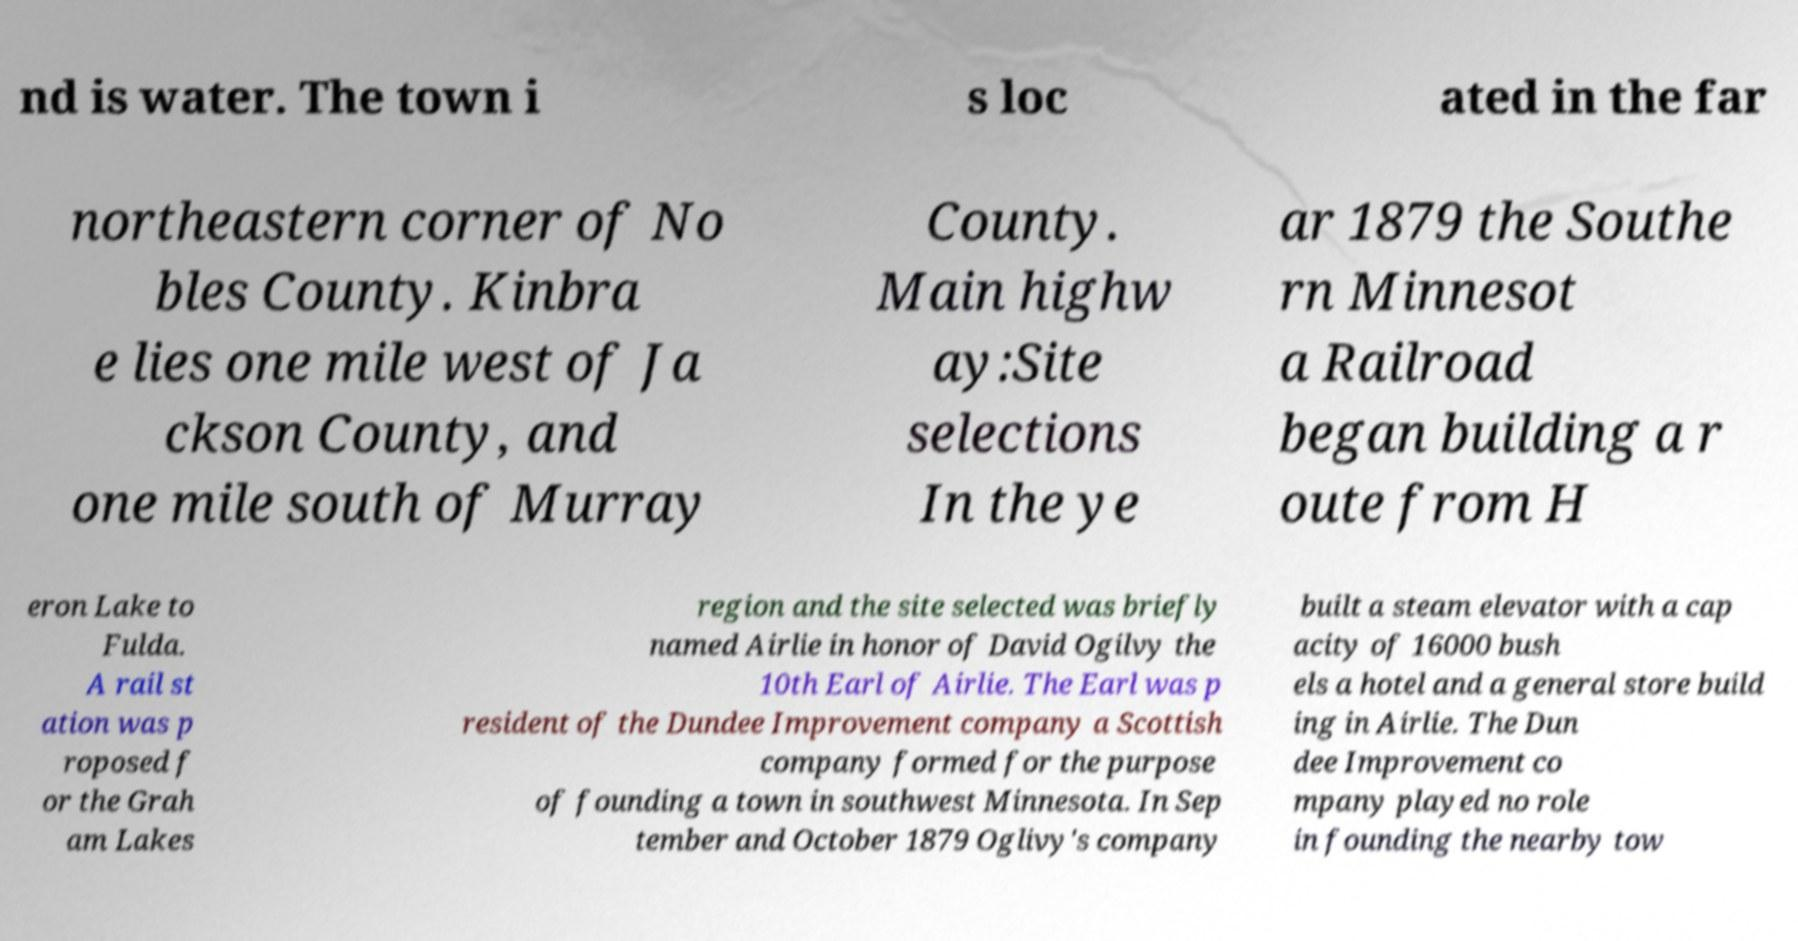Could you assist in decoding the text presented in this image and type it out clearly? nd is water. The town i s loc ated in the far northeastern corner of No bles County. Kinbra e lies one mile west of Ja ckson County, and one mile south of Murray County. Main highw ay:Site selections In the ye ar 1879 the Southe rn Minnesot a Railroad began building a r oute from H eron Lake to Fulda. A rail st ation was p roposed f or the Grah am Lakes region and the site selected was briefly named Airlie in honor of David Ogilvy the 10th Earl of Airlie. The Earl was p resident of the Dundee Improvement company a Scottish company formed for the purpose of founding a town in southwest Minnesota. In Sep tember and October 1879 Oglivy's company built a steam elevator with a cap acity of 16000 bush els a hotel and a general store build ing in Airlie. The Dun dee Improvement co mpany played no role in founding the nearby tow 